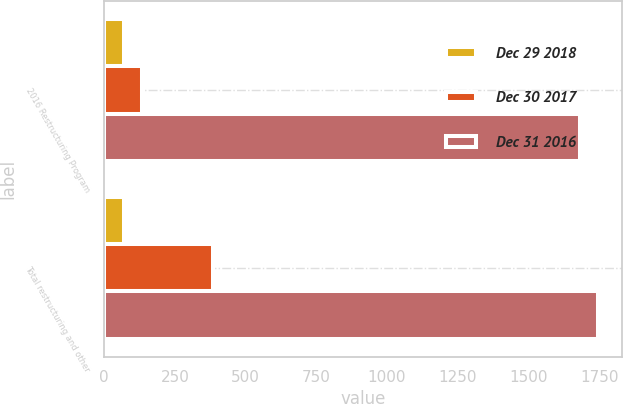Convert chart to OTSL. <chart><loc_0><loc_0><loc_500><loc_500><stacked_bar_chart><ecel><fcel>2016 Restructuring Program<fcel>Total restructuring and other<nl><fcel>Dec 29 2018<fcel>72<fcel>72<nl><fcel>Dec 30 2017<fcel>135<fcel>384<nl><fcel>Dec 31 2016<fcel>1681<fcel>1744<nl></chart> 